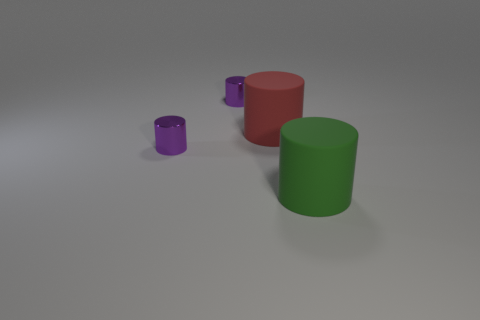Subtract all red cylinders. How many cylinders are left? 3 Subtract all large red cylinders. How many cylinders are left? 3 Subtract 2 cylinders. How many cylinders are left? 2 Add 1 purple shiny things. How many objects exist? 5 Subtract all gray cylinders. Subtract all blue balls. How many cylinders are left? 4 Subtract all tiny blue matte cylinders. Subtract all red cylinders. How many objects are left? 3 Add 1 small shiny cylinders. How many small shiny cylinders are left? 3 Add 3 big red metallic blocks. How many big red metallic blocks exist? 3 Subtract 0 green balls. How many objects are left? 4 